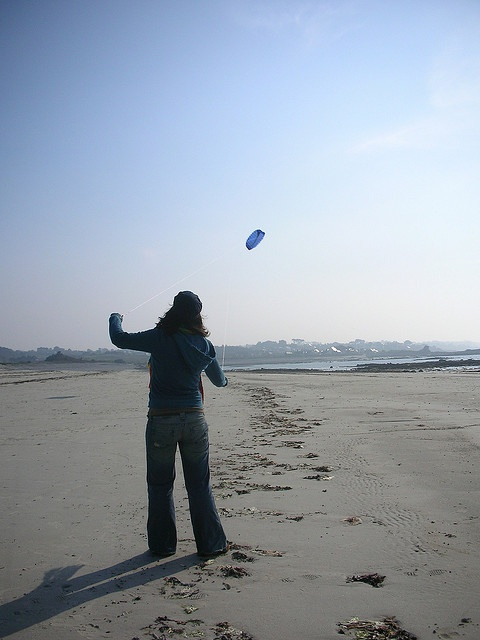Describe the objects in this image and their specific colors. I can see people in blue, black, gray, darkgray, and darkblue tones and frisbee in blue and gray tones in this image. 